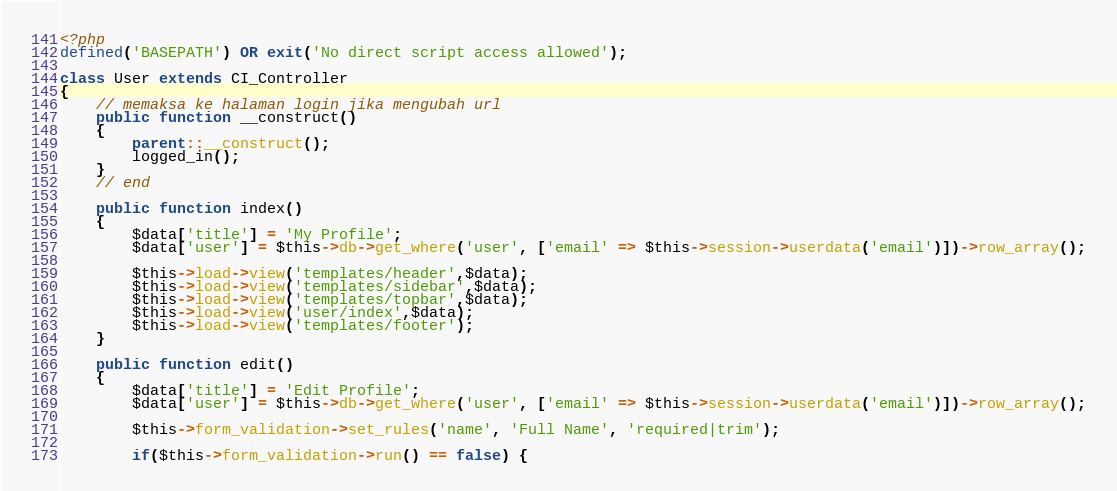Convert code to text. <code><loc_0><loc_0><loc_500><loc_500><_PHP_><?php
defined('BASEPATH') OR exit('No direct script access allowed');

class User extends CI_Controller 
{
	// memaksa ke halaman login jika mengubah url
	public function __construct()
	{
		parent::__construct();
		logged_in();
	}
	// end
	
	public function index()
	{
		$data['title'] = 'My Profile';
		$data['user'] = $this->db->get_where('user', ['email' => $this->session->userdata('email')])->row_array();

		$this->load->view('templates/header',$data);
		$this->load->view('templates/sidebar',$data);
		$this->load->view('templates/topbar',$data);
		$this->load->view('user/index',$data);
		$this->load->view('templates/footer');
	}

	public function edit()
	{
		$data['title'] = 'Edit Profile';
		$data['user'] = $this->db->get_where('user', ['email' => $this->session->userdata('email')])->row_array();

		$this->form_validation->set_rules('name', 'Full Name', 'required|trim');

		if($this->form_validation->run() == false) {</code> 